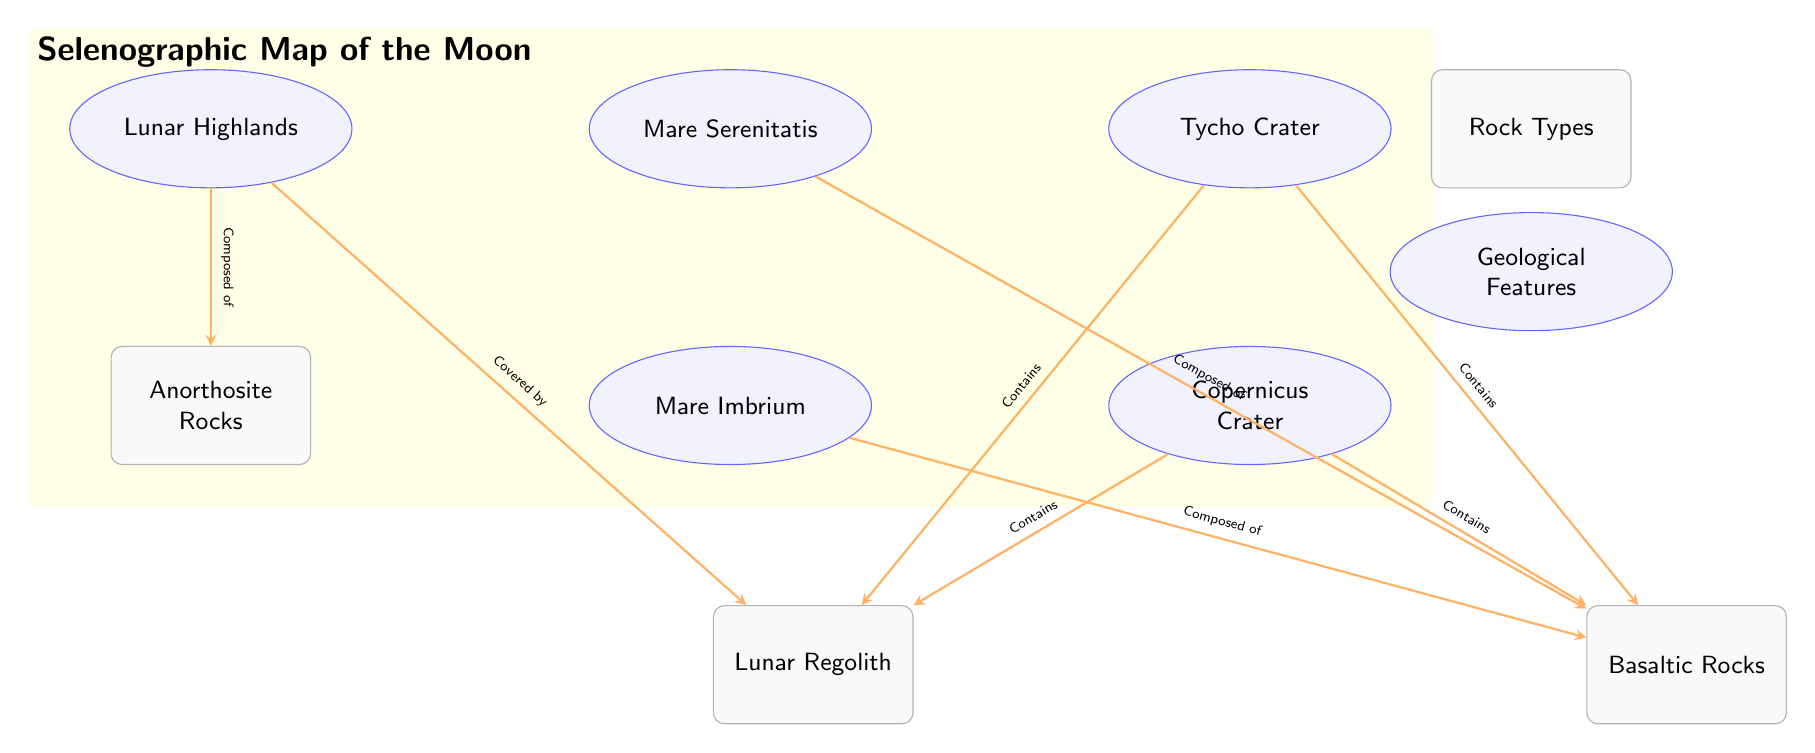What is the geological feature located to the right of Mare Serenitatis? According to the diagram, the feature to the right of Mare Serenitatis is labeled 'Tycho Crater'. Therefore, the answer is derived directly from the node placement in the diagram.
Answer: Tycho Crater How many geological features are depicted in the diagram? The diagram shows five geological features: Mare Serenitatis, Mare Imbrium, Tycho Crater, Copernicus Crater, and Lunar Highlands. By counting these nodes, we find the total for the answer.
Answer: 5 What type of rocks are found in Mare Imbrium? The diagram indicates that Mare Imbrium is composed of Basaltic Rocks, as shown by the connection leading from Mare Imbrium to the corresponding rock node.
Answer: Basaltic Rocks Which rock type is covered by Lunar Highlands? The connection from the Lunar Highlands to the Regolith indicates that this is the rock type covered by the highlands. The reasoning involves following the connection from the feature node to the rock type node.
Answer: Regolith What is the relationship between Tycho Crater and Basaltic Rocks? The diagram illustrates that Tycho Crater contains Basaltic Rocks, as indicated by the directed connection from Tycho Crater to the Basaltic Rocks node. This relationship is confirmed by reading the arrowed connection.
Answer: Contains How many types of rocks are mentioned in the diagram? There are three types of rocks referenced in the diagram: Anorthosite Rocks, Basaltic Rocks, and Regolith. This is accounted for by identifying each distinct rock node present within the diagram.
Answer: 3 Which geological feature is composed of Anorthosite Rocks? The connection shows that the Lunar Highlands are composed of Anorthosite Rocks, which is indicated explicitly on the diagram through the directed connection from the highlands to the rock type.
Answer: Lunar Highlands What kind of rocks are found in Copernicus Crater? The diagram states that Copernicus Crater contains both Basaltic Rocks and Regolith, demonstrated by two connections from the Copernicus Crater node to these rock type nodes. This can be confirmed by following each arrow.
Answer: Basaltic Rocks and Regolith 